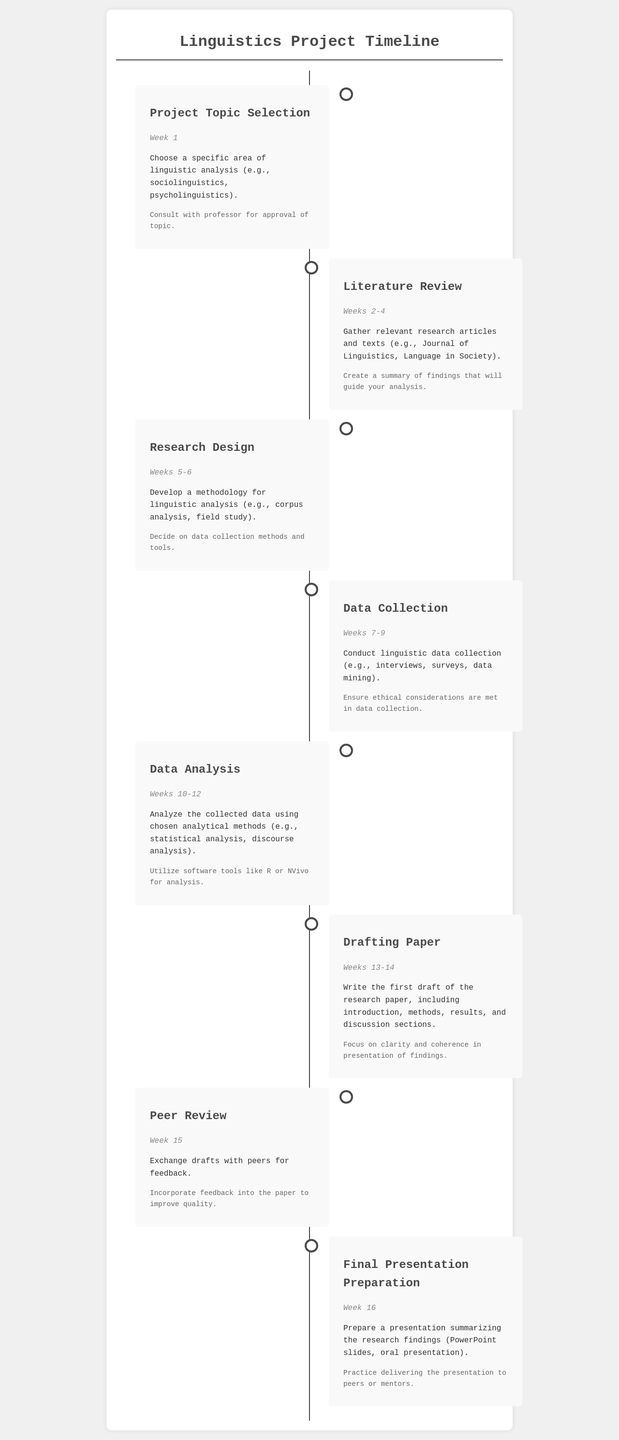What is the first phase of the project? The first phase of the project is the selection of a project topic, which is the starting point for the research process.
Answer: Project Topic Selection How long does the literature review phase last? The literature review phase spans several weeks, specifically from week 2 to week 4, which indicates its duration.
Answer: Weeks 2-4 What is the main focus of the data analysis phase? The data analysis phase emphasizes the evaluation and interpretation of the gathered data, using specified methods.
Answer: Analyze the collected data During which weeks does data collection occur? The data collection activity takes place over a specific time frame, determined to be weeks 7 to 9.
Answer: Weeks 7-9 What is one tool suggested for data analysis? This question identifies a tool recommended for performing analysis on data collected during the research process.
Answer: R or NVivo What should students do after the peer review phase? Following the peer review phase, students are advised to incorporate feedback to enhance the quality of their research paper.
Answer: Incorporate feedback How many weeks are allocated for drafting the paper? The question seeks to identify the specific duration designated for writing the first draft of the research paper.
Answer: Weeks 13-14 What is required for final presentation preparation? This question inquires about the components necessary for effectively preparing a presentation summarizing research findings.
Answer: PowerPoint slides, oral presentation 